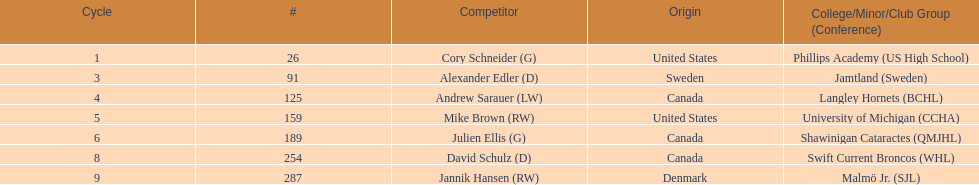Which players are not from denmark? Cory Schneider (G), Alexander Edler (D), Andrew Sarauer (LW), Mike Brown (RW), Julien Ellis (G), David Schulz (D). 